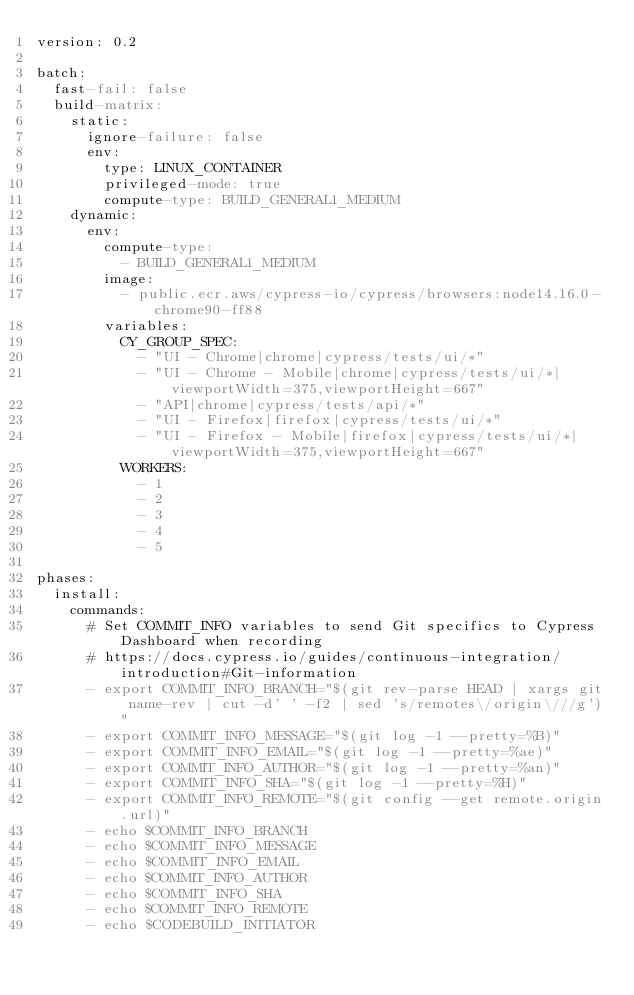Convert code to text. <code><loc_0><loc_0><loc_500><loc_500><_YAML_>version: 0.2

batch:
  fast-fail: false
  build-matrix:
    static:
      ignore-failure: false
      env:
        type: LINUX_CONTAINER
        privileged-mode: true
        compute-type: BUILD_GENERAL1_MEDIUM
    dynamic:
      env:
        compute-type:
          - BUILD_GENERAL1_MEDIUM
        image:
          - public.ecr.aws/cypress-io/cypress/browsers:node14.16.0-chrome90-ff88
        variables:
          CY_GROUP_SPEC:
            - "UI - Chrome|chrome|cypress/tests/ui/*"
            - "UI - Chrome - Mobile|chrome|cypress/tests/ui/*|viewportWidth=375,viewportHeight=667"
            - "API|chrome|cypress/tests/api/*"
            - "UI - Firefox|firefox|cypress/tests/ui/*"
            - "UI - Firefox - Mobile|firefox|cypress/tests/ui/*|viewportWidth=375,viewportHeight=667"
          WORKERS:
            - 1
            - 2
            - 3
            - 4
            - 5

phases:
  install:
    commands:
      # Set COMMIT_INFO variables to send Git specifics to Cypress Dashboard when recording
      # https://docs.cypress.io/guides/continuous-integration/introduction#Git-information
      - export COMMIT_INFO_BRANCH="$(git rev-parse HEAD | xargs git name-rev | cut -d' ' -f2 | sed 's/remotes\/origin\///g')"
      - export COMMIT_INFO_MESSAGE="$(git log -1 --pretty=%B)"
      - export COMMIT_INFO_EMAIL="$(git log -1 --pretty=%ae)"
      - export COMMIT_INFO_AUTHOR="$(git log -1 --pretty=%an)"
      - export COMMIT_INFO_SHA="$(git log -1 --pretty=%H)"
      - export COMMIT_INFO_REMOTE="$(git config --get remote.origin.url)"
      - echo $COMMIT_INFO_BRANCH
      - echo $COMMIT_INFO_MESSAGE
      - echo $COMMIT_INFO_EMAIL
      - echo $COMMIT_INFO_AUTHOR
      - echo $COMMIT_INFO_SHA
      - echo $COMMIT_INFO_REMOTE
      - echo $CODEBUILD_INITIATOR</code> 